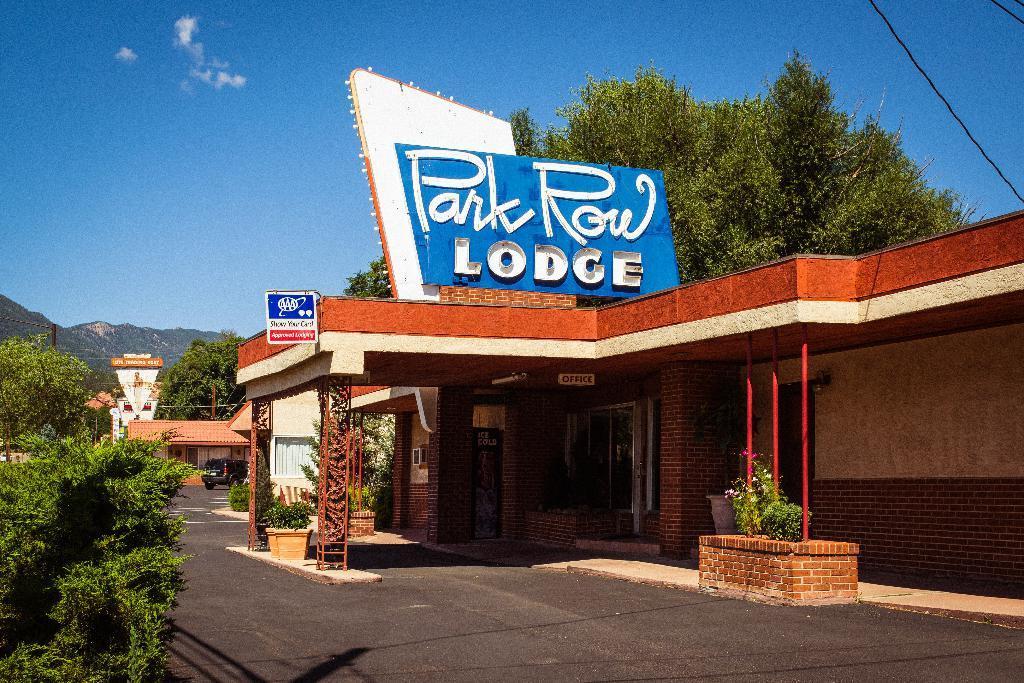Describe this image in one or two sentences. In this image we can see the buildings, there are boards with text on it, also we can see some trees, plants, flowers, mountains and a vehicle, in the background we can see the sky with clouds. 